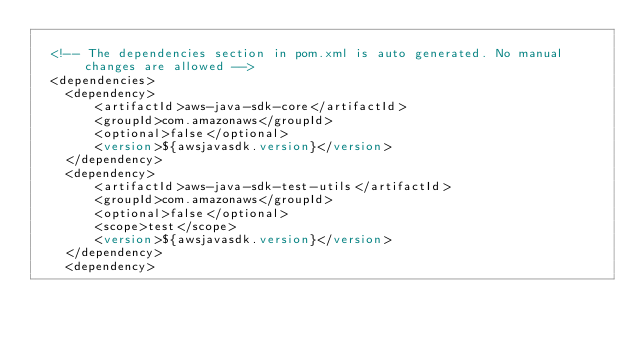Convert code to text. <code><loc_0><loc_0><loc_500><loc_500><_XML_>
  <!-- The dependencies section in pom.xml is auto generated. No manual changes are allowed -->
  <dependencies>
    <dependency>
        <artifactId>aws-java-sdk-core</artifactId>
        <groupId>com.amazonaws</groupId>
        <optional>false</optional>
        <version>${awsjavasdk.version}</version>
    </dependency>
    <dependency>
        <artifactId>aws-java-sdk-test-utils</artifactId>
        <groupId>com.amazonaws</groupId>
        <optional>false</optional>
        <scope>test</scope>
        <version>${awsjavasdk.version}</version>
    </dependency>
    <dependency></code> 